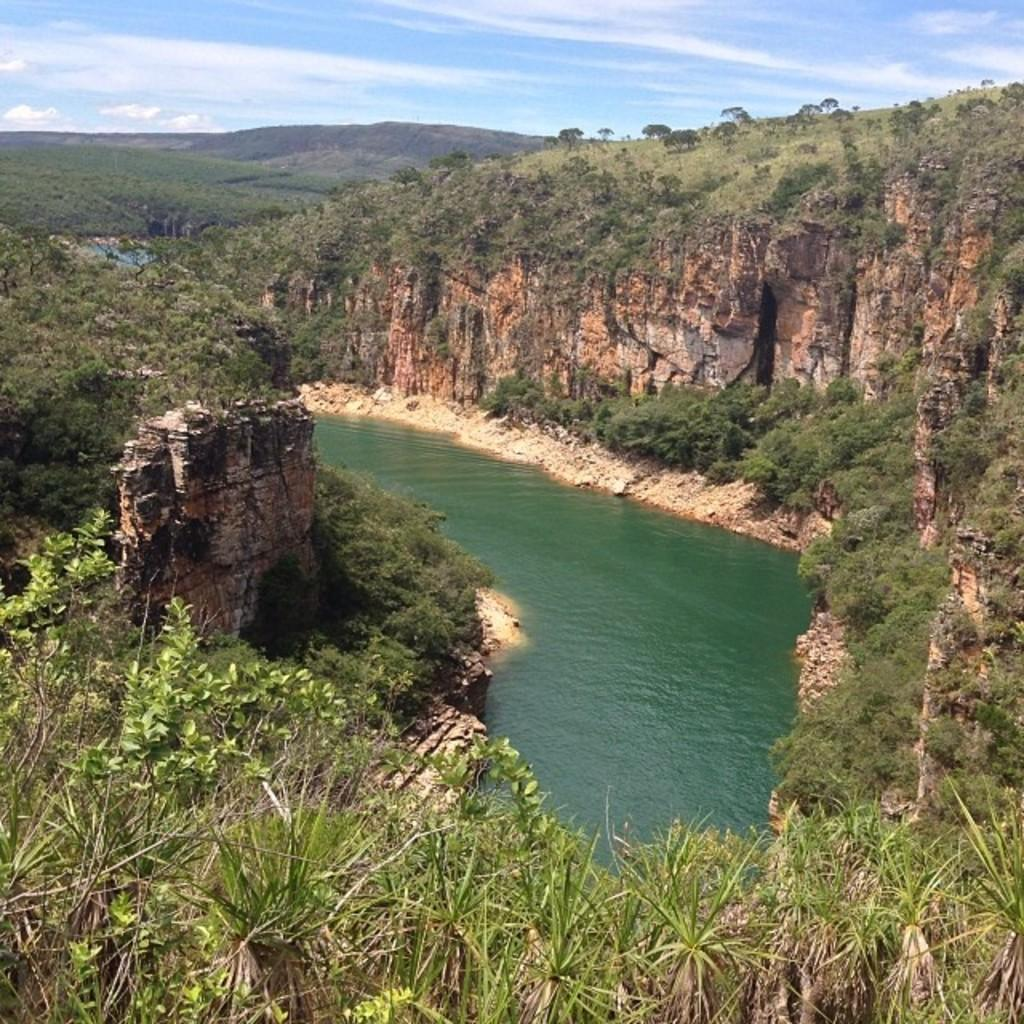What is the main feature visible on the water surface in the image? There is no specific feature visible on the water surface in the image. What type of vegetation covers the hills in the image? The hills are covered with grass and plants in the image. How many hills can be seen in the background of the image? There are hills visible in the background of the image. What is visible in the sky in the image? The sky is visible in the background of the image, and clouds are present. Can you tell me how many cacti are growing on the hills in the image? There are no cacti visible in the image; the hills are covered with grass and plants. 